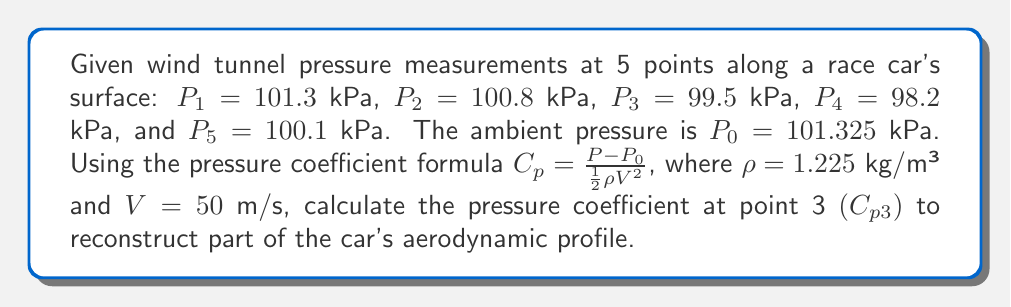Can you answer this question? To solve this problem, we'll follow these steps:

1) Recall the pressure coefficient formula:
   $$C_p = \frac{P - P_0}{\frac{1}{2}\rho V^2}$$

2) We're given:
   $P_3 = 99.5$ kPa
   $P_0 = 101.325$ kPa
   $\rho = 1.225$ kg/m³
   $V = 50$ m/s

3) First, calculate the denominator $\frac{1}{2}\rho V^2$:
   $$\frac{1}{2} \cdot 1.225 \cdot 50^2 = 1531.25 \text{ Pa} = 1.53125 \text{ kPa}$$

4) Now, calculate the pressure difference $(P - P_0)$:
   $$99.5 - 101.325 = -1.825 \text{ kPa}$$

5) Finally, divide the pressure difference by the denominator:
   $$C_{p3} = \frac{-1.825}{1.53125} = -1.1919$$

This negative pressure coefficient indicates that the air pressure at point 3 is lower than the ambient pressure, suggesting an area of accelerated airflow over the car's surface at this point.
Answer: $C_{p3} = -1.1919$ 